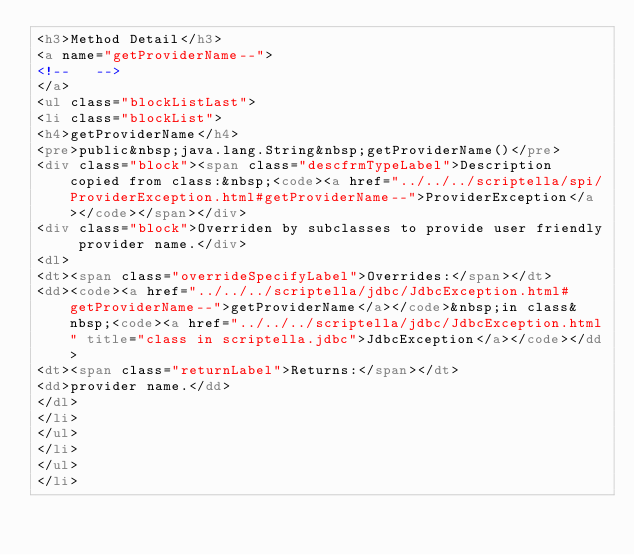<code> <loc_0><loc_0><loc_500><loc_500><_HTML_><h3>Method Detail</h3>
<a name="getProviderName--">
<!--   -->
</a>
<ul class="blockListLast">
<li class="blockList">
<h4>getProviderName</h4>
<pre>public&nbsp;java.lang.String&nbsp;getProviderName()</pre>
<div class="block"><span class="descfrmTypeLabel">Description copied from class:&nbsp;<code><a href="../../../scriptella/spi/ProviderException.html#getProviderName--">ProviderException</a></code></span></div>
<div class="block">Overriden by subclasses to provide user friendly provider name.</div>
<dl>
<dt><span class="overrideSpecifyLabel">Overrides:</span></dt>
<dd><code><a href="../../../scriptella/jdbc/JdbcException.html#getProviderName--">getProviderName</a></code>&nbsp;in class&nbsp;<code><a href="../../../scriptella/jdbc/JdbcException.html" title="class in scriptella.jdbc">JdbcException</a></code></dd>
<dt><span class="returnLabel">Returns:</span></dt>
<dd>provider name.</dd>
</dl>
</li>
</ul>
</li>
</ul>
</li></code> 